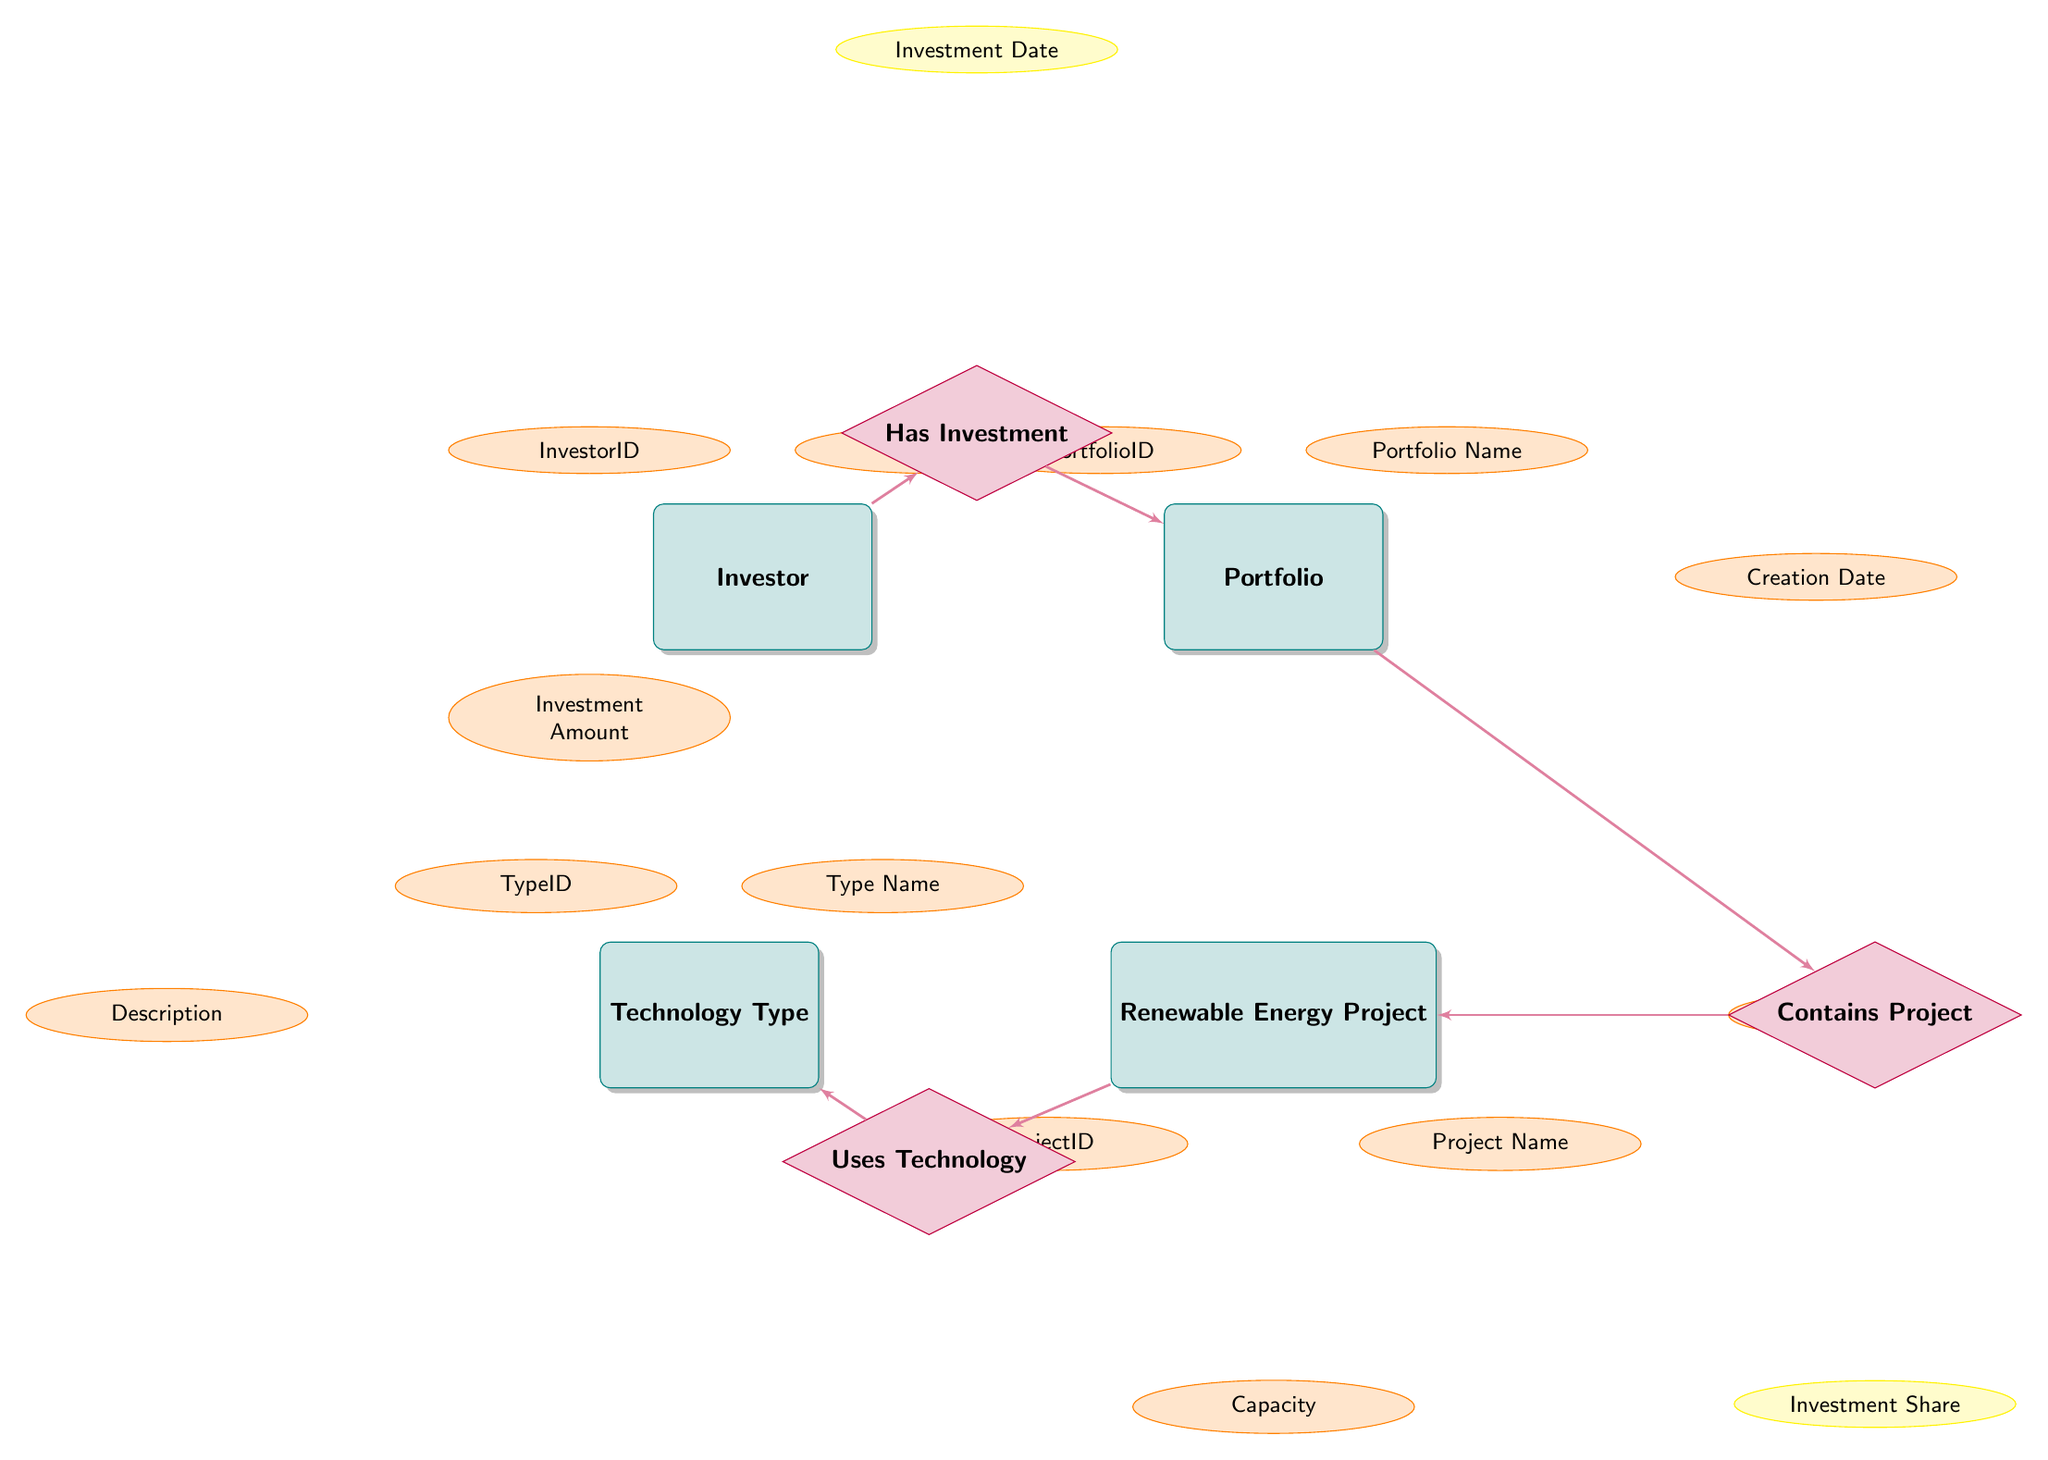What is the name of the relationship between Investor and Portfolio? The relationship between Investor and Portfolio is labeled as "Has Investment" in the diagram.
Answer: Has Investment What type of node is "Renewable Energy Project"? "Renewable Energy Project" is categorized as an entity in the diagram. It is a rectangle with attributes associated with it.
Answer: Entity How many attributes does the Technology Type entity have? The Technology Type entity has three attributes: TypeID, TypeName, and Description.
Answer: Three What does the attribute "Investment Share" indicate in the diagram? The attribute "Investment Share" is linked to the relationship "Contains Project," which indicates the share of investment allocated to each Renewable Energy Project in a given Portfolio.
Answer: Investment Share Which entity is connected to Technology Type through the "Uses Technology" relationship? The "Uses Technology" relationship connects the Renewable Energy Project entity to the Technology Type entity.
Answer: Renewable Energy Project What is one of the attributes of the Portfolio entity? One of the attributes of the Portfolio entity is "Portfolio Name."
Answer: Portfolio Name What is the significance of the attribute "Investment Date"? "Investment Date" is an attribute that specifies when the investment was made, linked to the relationship "Has Investment" between Investor and Portfolio.
Answer: Investment Date How many entities are present in the diagram? The diagram contains four entities: Investor, Portfolio, Renewable Energy Project, and Technology Type.
Answer: Four Which entity has an attribute called "Capacity"? The Renewable Energy Project entity has an attribute called "Capacity" that indicates the energy output capability of the project.
Answer: Renewable Energy Project Is there a direct relationship between the Portfolio and Technology Type entities? No, there is no direct relationship between Portfolio and Technology Type entities; the relationship is indirect through the Renewable Energy Project.
Answer: No 